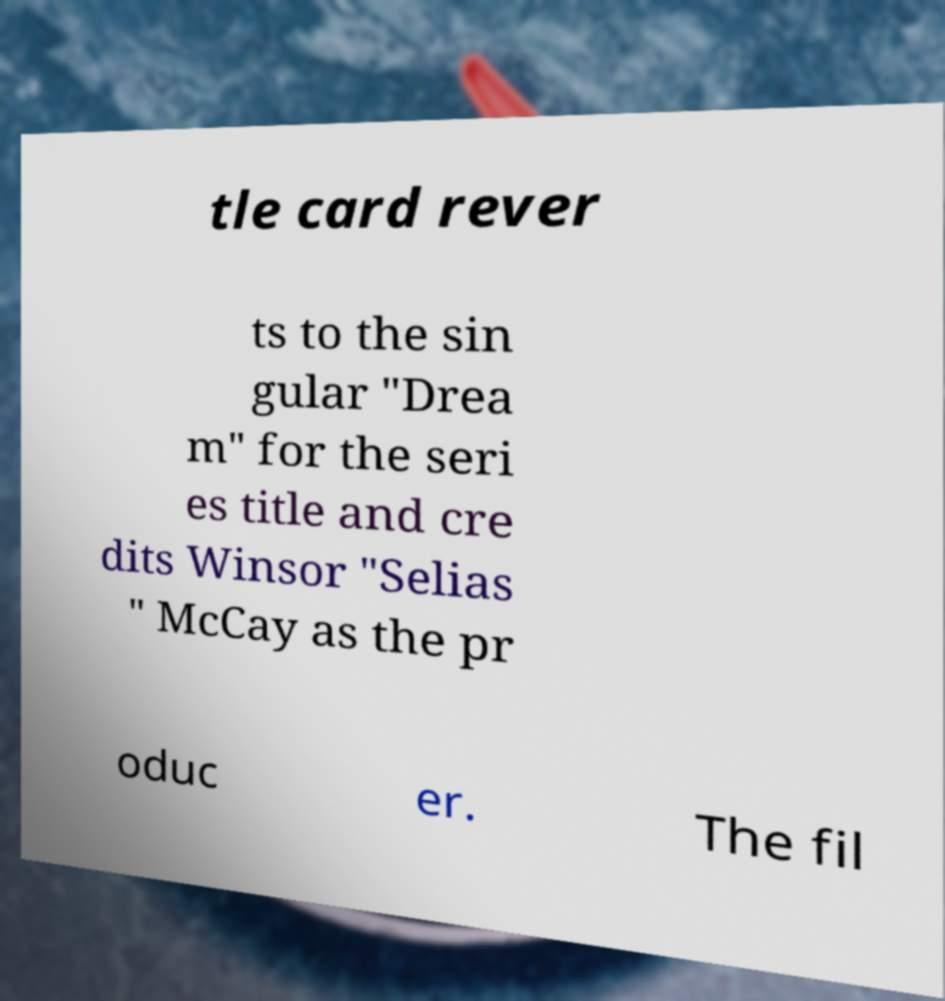I need the written content from this picture converted into text. Can you do that? tle card rever ts to the sin gular "Drea m" for the seri es title and cre dits Winsor "Selias " McCay as the pr oduc er. The fil 